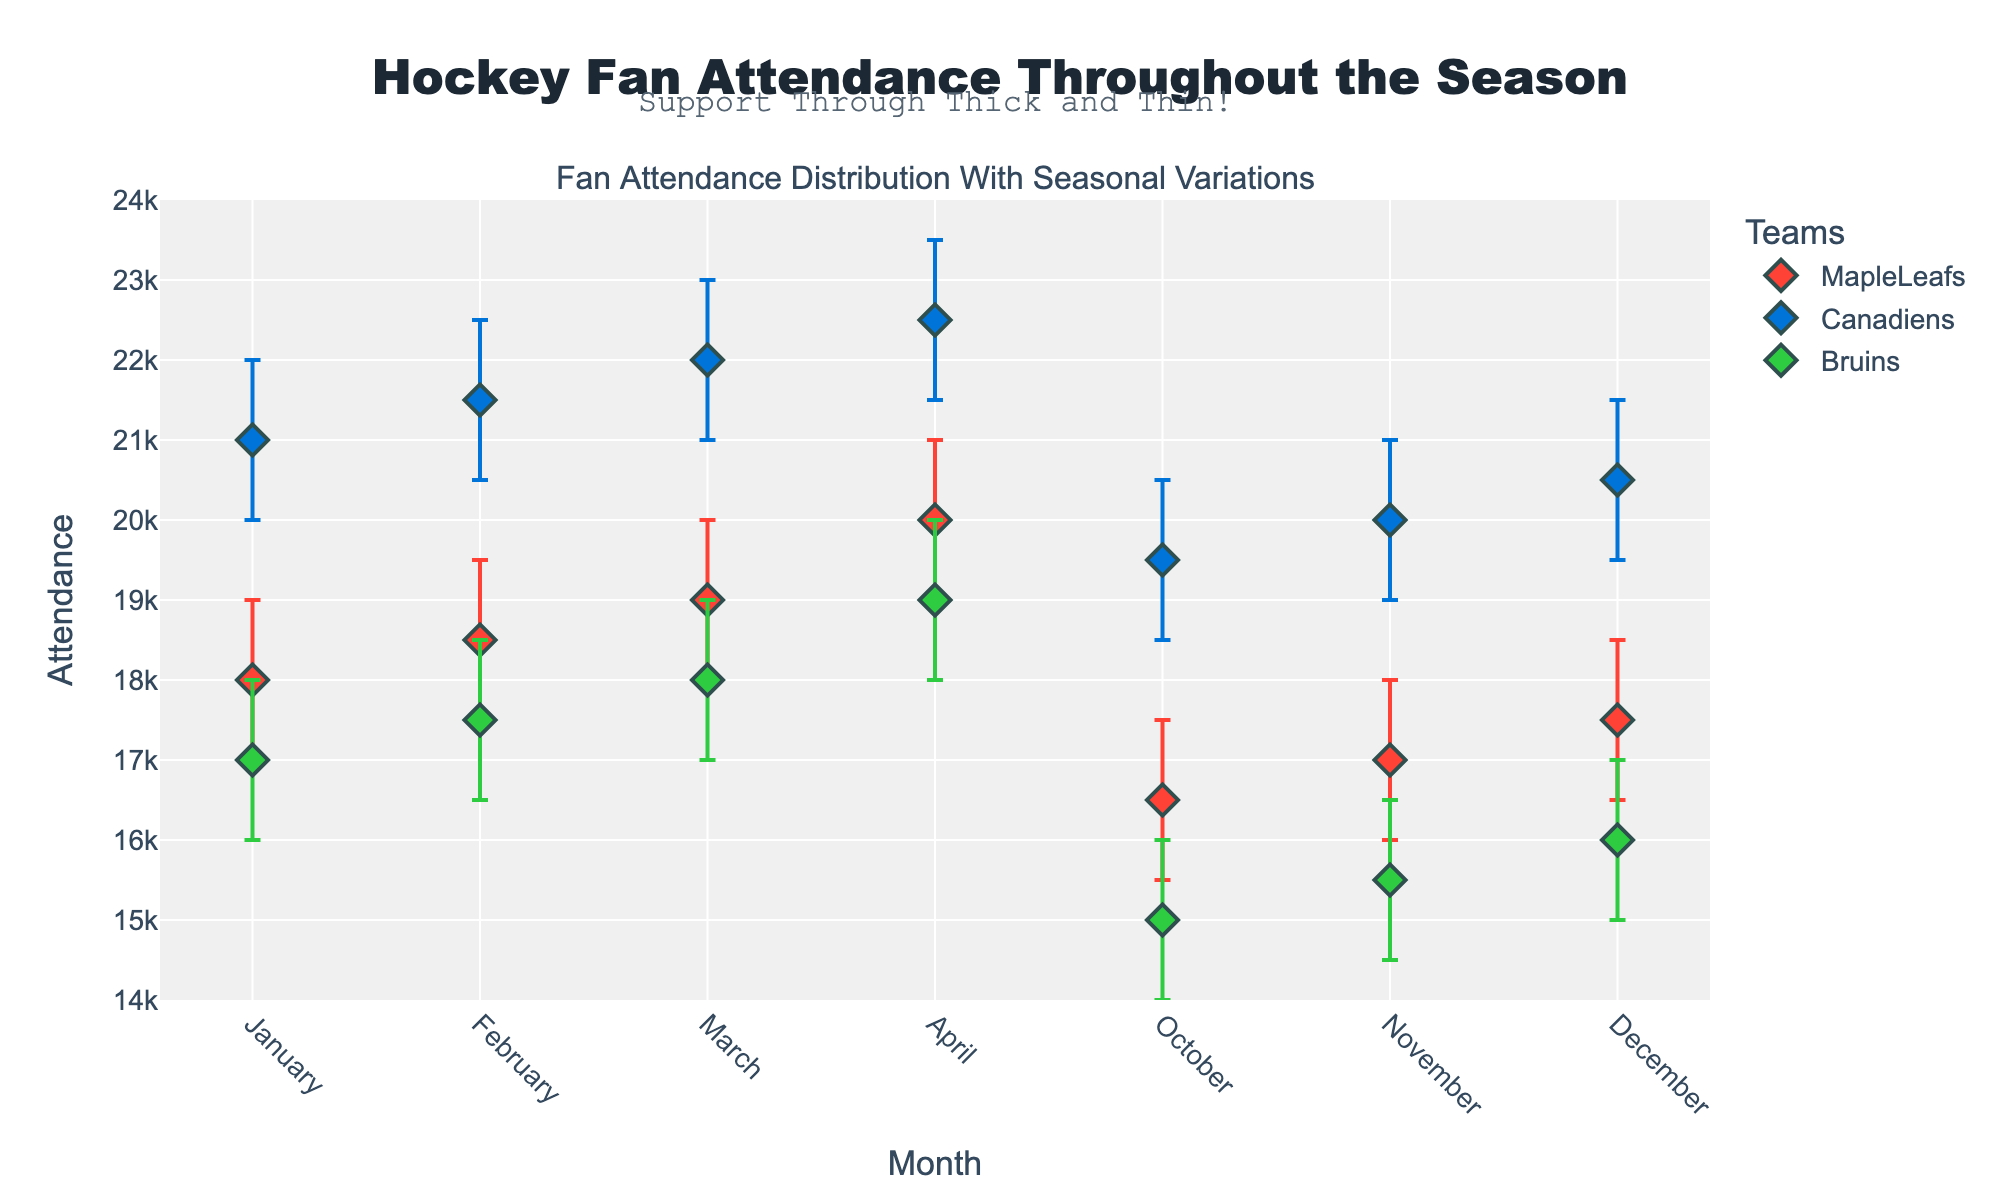What is the title of the plot? The title of the plot is located at the top center. It reads "Hockey Fan Attendance Throughout the Season."
Answer: Hockey Fan Attendance Throughout the Season How many teams are represented in the plot? There are three different colored markers representing each team: the Maple Leafs, Canadiens, and Bruins.
Answer: Three Which team has the highest attendance in April? Look at the data points corresponding to April. The Canadiens have the highest attendance value among the teams.
Answer: Canadiens What is the range of attendance for the Bruins in March? The Bruins have an attendance value of 18,000 in March, with error bars extending from 17,000 to 19,000. The range is obtained by subtracting the lower value from the higher value, 19,000 - 17,000.
Answer: 2,000 What is the average attendance of the Maple Leafs across all months? Sum the attendance values for the Maple Leafs across all months and divide by the number of months: (18000 + 18500 + 19000 + 20000 + 16500 + 17000 + 17500) / 7 = 166500 / 7.
Answer: 18,786 Which months do the Maple Leafs have their highest and lowest attendance? By comparing the attendance values for the Maple Leafs across all months, April has the highest attendance at 20,000 and October has the lowest at 16,500.
Answer: Highest: April, Lowest: October Which team has shown the most consistent attendance across the season? The team with the smallest variation in the error bars represents the most consistent attendance. The Canadiens’ error bars have the smallest variation across the months.
Answer: Canadiens What is the attendance difference between the Maple Leafs and Bruins in January? The Maple Leafs' attendance in January is 18,000, and the Bruins' attendance in January is 17,000. The difference is 18,000 - 17,000.
Answer: 1,000 In which month does the Bruins' attendance first exceed 16,000? Locate the months where Bruins' attendance exceeds 16,000. The first month this occurs is in November with an attendance of 15,500 (this value does not meet the criterion), followed by December with an attendance of 16,000, and then January with an attendance of 17,000. January is the correct month.
Answer: January What is the overall trend of fan attendance from October to April for each team? Observe the changes in attendance from October to April for each team. All teams show an increasing trend in fan attendance from October to April.
Answer: Increasing Trend 